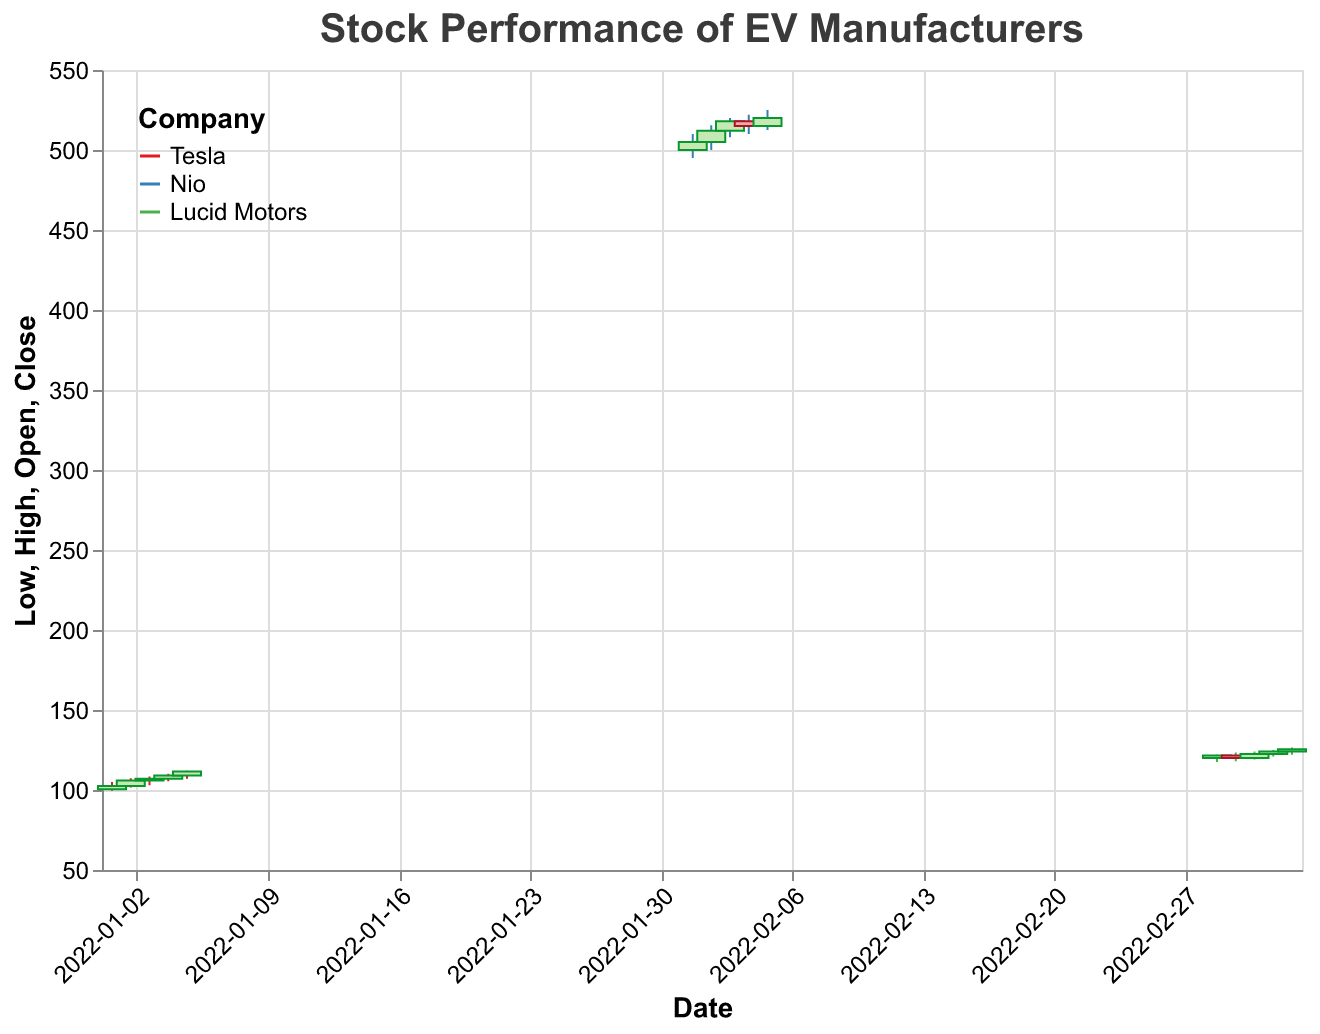what is the date range shown in the figure? The date range can be determined by looking at the x-axis, which shows the time series of the data points from the earliest to the latest date.
Answer: 2022-01-01 to 2022-03-05 Which company has the highest closing price? By examining the heights of the bars (the closing price) and the colors representing different companies, we can identify the company with the highest closing price. Nio has a closing price of 520.0 on 2022-02-05, which is the highest.
Answer: Nio What was Tesla's closing price on the last date of its data points? For Tesla, locate the last date on the x-axis where Tesla's data points appear. The closing price on 2022-01-05 is 111.5. This value can be found at the higher end of Tesla’s time series.
Answer: 111.5 Which company had the biggest price increase over a single day? To find this, calculate the difference between the open and close prices for all the companies and identify the largest positive change. Tesla's biggest increase is from 107.0 to 111.5 on 2022-01-05, which is 4.5. Nio's biggest increase is from 500.0 to 505.0 on 2022-02-01, which is 10. Lucid Motors' biggest increase is from 122.0 to 124.0 on 2022-03-04, which is 2.5. Therefore, Nio had the largest increase.
Answer: Nio What is the average closing price for Lucid Motors in March? Add up the closing prices for Lucid Motors in March: 121.5, 120.0, 122.5, 124.0, 125.5. Then divide by the number of days: (121.5 + 120.0 + 122.5 + 124.0 + 125.5) / 5 = 613.5 / 5.
Answer: 122.7 How did the volume of shares traded for Tesla change over its data points? Examine the volume values for Tesla and note the pattern: 1,000,000, 1,100,000, 1,050,000, 1,150,000, 1,200,000. The volume generally increased, with some fluctuations.
Answer: Increased Which's company stock showed the least volatility in their high and low prices? Volatility can be observed by examining the range (high - low) for each company. The smaller the range, the less volatile the stock. Tesla: (105.0 - 99.5) = 5.5, Nio: (525.0 - 495.0) = 30, Lucid Motors: (126.5 - 117.5) = 9. The smallest range is for Tesla.
Answer: Tesla What’s the color legend representing each company? By referring to the legend at the top-left of the figure, we can interpret the colors used for each company. Tesla is red, Nio is blue, and Lucid Motors is green.
Answer: Tesla is red, Nio is blue, Lucid Motors is green 